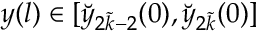Convert formula to latex. <formula><loc_0><loc_0><loc_500><loc_500>y ( l ) \in [ \breve { y } _ { 2 \tilde { k } - 2 } ( 0 ) , \breve { y } _ { 2 \tilde { k } } ( 0 ) ]</formula> 